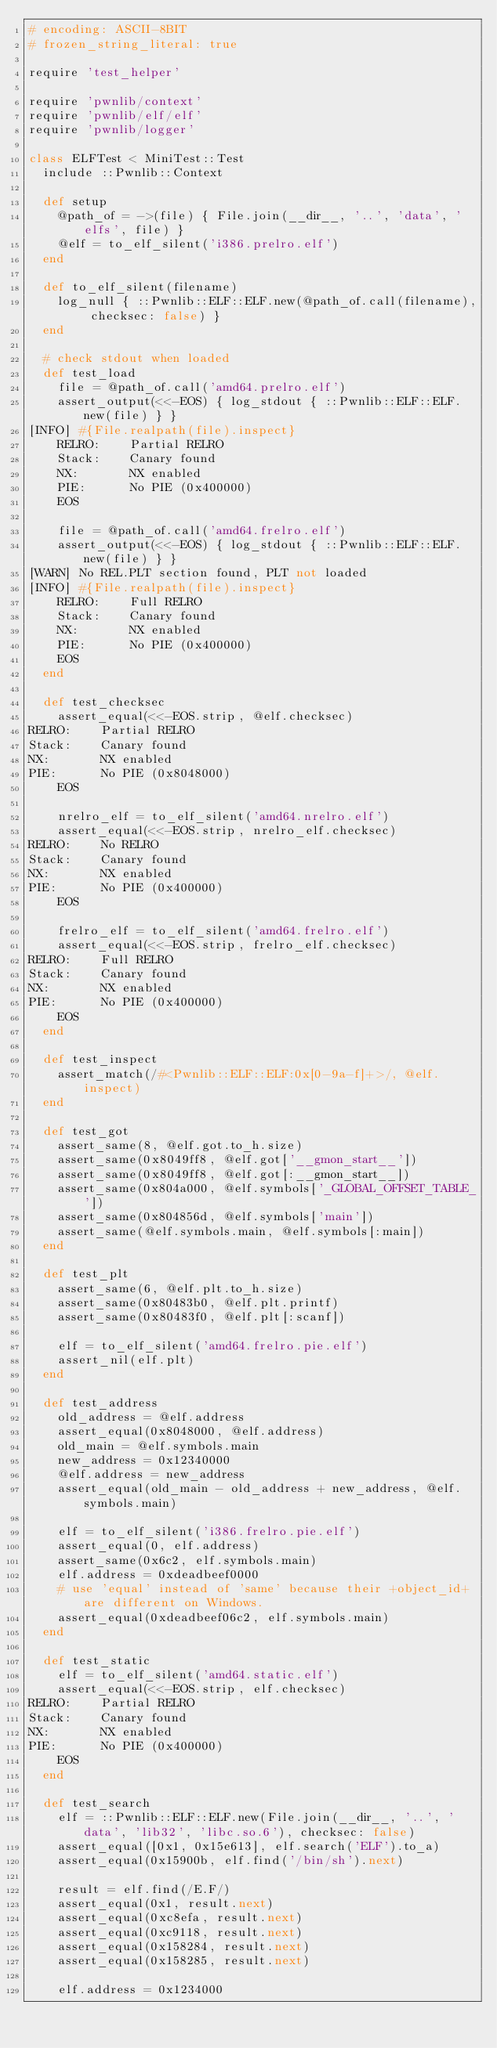<code> <loc_0><loc_0><loc_500><loc_500><_Ruby_># encoding: ASCII-8BIT
# frozen_string_literal: true

require 'test_helper'

require 'pwnlib/context'
require 'pwnlib/elf/elf'
require 'pwnlib/logger'

class ELFTest < MiniTest::Test
  include ::Pwnlib::Context

  def setup
    @path_of = ->(file) { File.join(__dir__, '..', 'data', 'elfs', file) }
    @elf = to_elf_silent('i386.prelro.elf')
  end

  def to_elf_silent(filename)
    log_null { ::Pwnlib::ELF::ELF.new(@path_of.call(filename), checksec: false) }
  end

  # check stdout when loaded
  def test_load
    file = @path_of.call('amd64.prelro.elf')
    assert_output(<<-EOS) { log_stdout { ::Pwnlib::ELF::ELF.new(file) } }
[INFO] #{File.realpath(file).inspect}
    RELRO:    Partial RELRO
    Stack:    Canary found
    NX:       NX enabled
    PIE:      No PIE (0x400000)
    EOS

    file = @path_of.call('amd64.frelro.elf')
    assert_output(<<-EOS) { log_stdout { ::Pwnlib::ELF::ELF.new(file) } }
[WARN] No REL.PLT section found, PLT not loaded
[INFO] #{File.realpath(file).inspect}
    RELRO:    Full RELRO
    Stack:    Canary found
    NX:       NX enabled
    PIE:      No PIE (0x400000)
    EOS
  end

  def test_checksec
    assert_equal(<<-EOS.strip, @elf.checksec)
RELRO:    Partial RELRO
Stack:    Canary found
NX:       NX enabled
PIE:      No PIE (0x8048000)
    EOS

    nrelro_elf = to_elf_silent('amd64.nrelro.elf')
    assert_equal(<<-EOS.strip, nrelro_elf.checksec)
RELRO:    No RELRO
Stack:    Canary found
NX:       NX enabled
PIE:      No PIE (0x400000)
    EOS

    frelro_elf = to_elf_silent('amd64.frelro.elf')
    assert_equal(<<-EOS.strip, frelro_elf.checksec)
RELRO:    Full RELRO
Stack:    Canary found
NX:       NX enabled
PIE:      No PIE (0x400000)
    EOS
  end

  def test_inspect
    assert_match(/#<Pwnlib::ELF::ELF:0x[0-9a-f]+>/, @elf.inspect)
  end

  def test_got
    assert_same(8, @elf.got.to_h.size)
    assert_same(0x8049ff8, @elf.got['__gmon_start__'])
    assert_same(0x8049ff8, @elf.got[:__gmon_start__])
    assert_same(0x804a000, @elf.symbols['_GLOBAL_OFFSET_TABLE_'])
    assert_same(0x804856d, @elf.symbols['main'])
    assert_same(@elf.symbols.main, @elf.symbols[:main])
  end

  def test_plt
    assert_same(6, @elf.plt.to_h.size)
    assert_same(0x80483b0, @elf.plt.printf)
    assert_same(0x80483f0, @elf.plt[:scanf])

    elf = to_elf_silent('amd64.frelro.pie.elf')
    assert_nil(elf.plt)
  end

  def test_address
    old_address = @elf.address
    assert_equal(0x8048000, @elf.address)
    old_main = @elf.symbols.main
    new_address = 0x12340000
    @elf.address = new_address
    assert_equal(old_main - old_address + new_address, @elf.symbols.main)

    elf = to_elf_silent('i386.frelro.pie.elf')
    assert_equal(0, elf.address)
    assert_same(0x6c2, elf.symbols.main)
    elf.address = 0xdeadbeef0000
    # use 'equal' instead of 'same' because their +object_id+ are different on Windows.
    assert_equal(0xdeadbeef06c2, elf.symbols.main)
  end

  def test_static
    elf = to_elf_silent('amd64.static.elf')
    assert_equal(<<-EOS.strip, elf.checksec)
RELRO:    Partial RELRO
Stack:    Canary found
NX:       NX enabled
PIE:      No PIE (0x400000)
    EOS
  end

  def test_search
    elf = ::Pwnlib::ELF::ELF.new(File.join(__dir__, '..', 'data', 'lib32', 'libc.so.6'), checksec: false)
    assert_equal([0x1, 0x15e613], elf.search('ELF').to_a)
    assert_equal(0x15900b, elf.find('/bin/sh').next)

    result = elf.find(/E.F/)
    assert_equal(0x1, result.next)
    assert_equal(0xc8efa, result.next)
    assert_equal(0xc9118, result.next)
    assert_equal(0x158284, result.next)
    assert_equal(0x158285, result.next)

    elf.address = 0x1234000</code> 